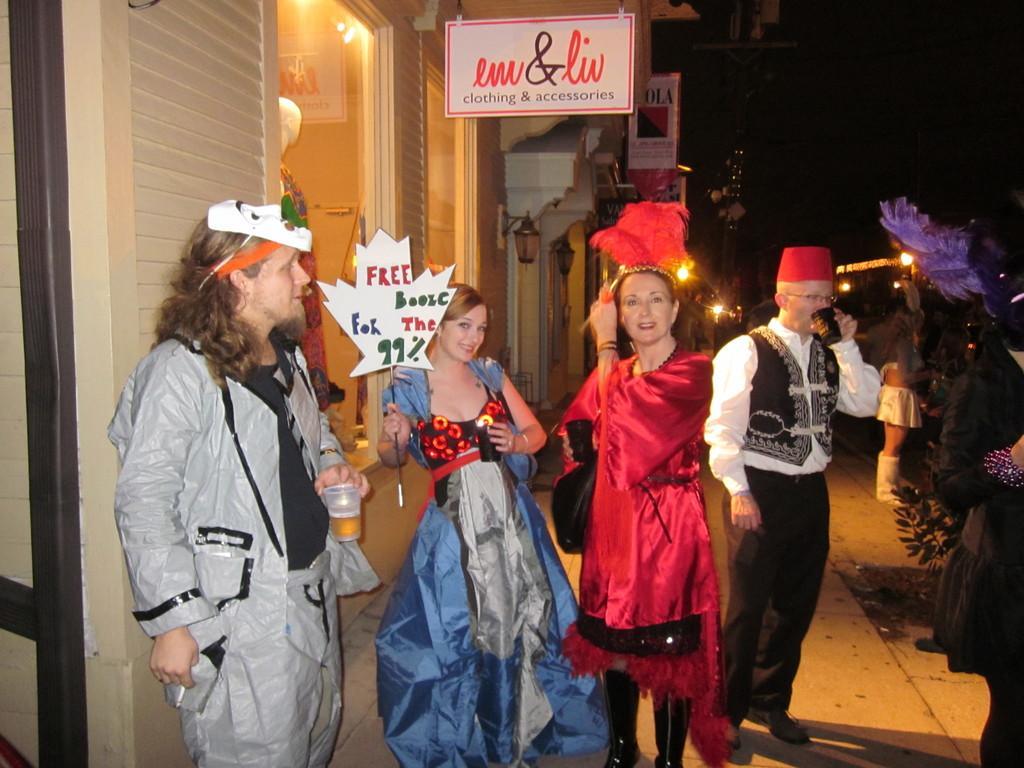Please provide a concise description of this image. In this image I can see few people standing and wearing different costumes. They are holding glass and boards. Back I can see buildings and lights. I can see mannequin doll. 